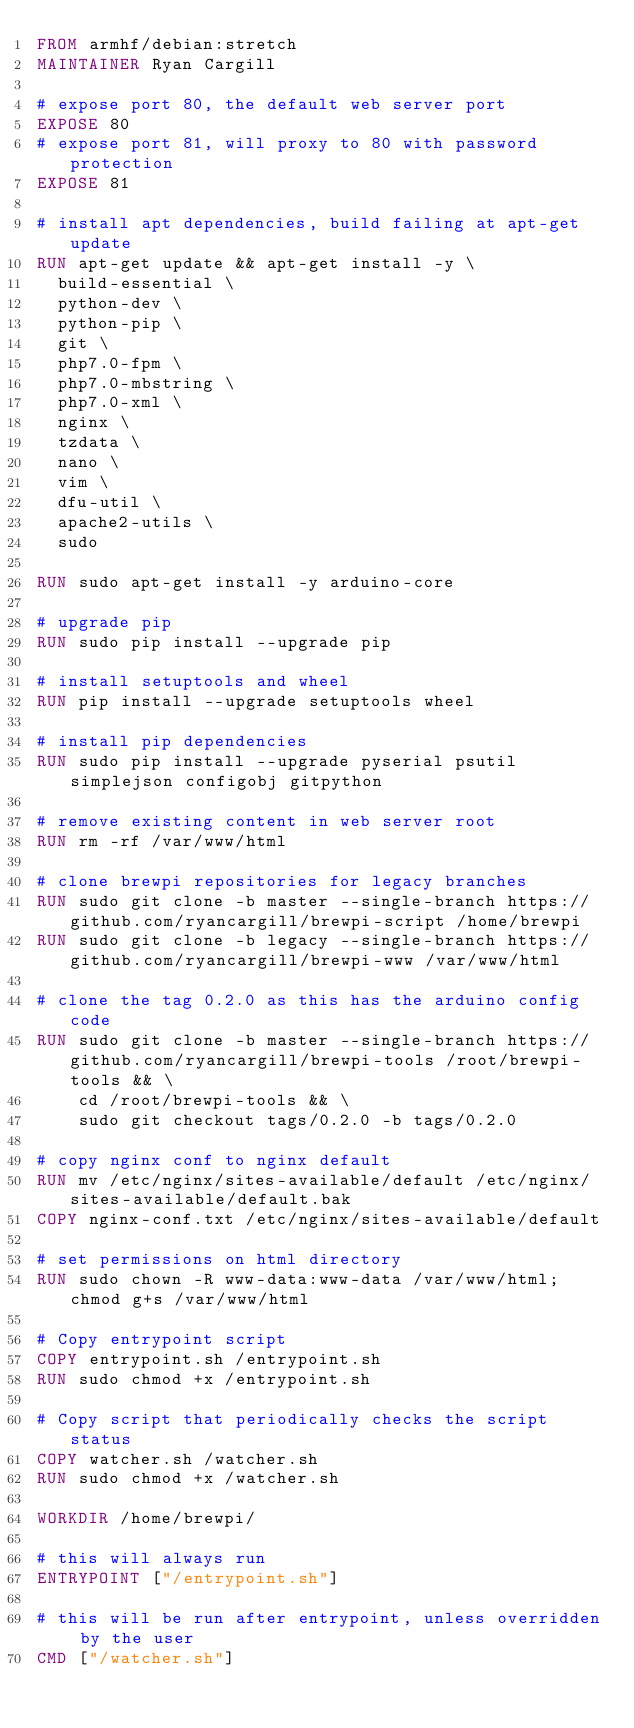Convert code to text. <code><loc_0><loc_0><loc_500><loc_500><_Dockerfile_>FROM armhf/debian:stretch
MAINTAINER Ryan Cargill

# expose port 80, the default web server port
EXPOSE 80
# expose port 81, will proxy to 80 with password protection
EXPOSE 81

# install apt dependencies, build failing at apt-get update
RUN apt-get update && apt-get install -y \
  build-essential \
  python-dev \
  python-pip \
  git \
  php7.0-fpm \
  php7.0-mbstring \
  php7.0-xml \
  nginx \
  tzdata \
  nano \
  vim \
  dfu-util \
  apache2-utils \
  sudo

RUN sudo apt-get install -y arduino-core

# upgrade pip
RUN sudo pip install --upgrade pip

# install setuptools and wheel
RUN pip install --upgrade setuptools wheel

# install pip dependencies
RUN sudo pip install --upgrade pyserial psutil simplejson configobj gitpython

# remove existing content in web server root
RUN rm -rf /var/www/html

# clone brewpi repositories for legacy branches
RUN sudo git clone -b master --single-branch https://github.com/ryancargill/brewpi-script /home/brewpi
RUN sudo git clone -b legacy --single-branch https://github.com/ryancargill/brewpi-www /var/www/html

# clone the tag 0.2.0 as this has the arduino config code
RUN sudo git clone -b master --single-branch https://github.com/ryancargill/brewpi-tools /root/brewpi-tools && \
    cd /root/brewpi-tools && \
    sudo git checkout tags/0.2.0 -b tags/0.2.0

# copy nginx conf to nginx default
RUN mv /etc/nginx/sites-available/default /etc/nginx/sites-available/default.bak
COPY nginx-conf.txt /etc/nginx/sites-available/default

# set permissions on html directory
RUN sudo chown -R www-data:www-data /var/www/html; chmod g+s /var/www/html

# Copy entrypoint script
COPY entrypoint.sh /entrypoint.sh
RUN sudo chmod +x /entrypoint.sh

# Copy script that periodically checks the script status
COPY watcher.sh /watcher.sh
RUN sudo chmod +x /watcher.sh

WORKDIR /home/brewpi/

# this will always run
ENTRYPOINT ["/entrypoint.sh"]

# this will be run after entrypoint, unless overridden by the user
CMD ["/watcher.sh"]
</code> 